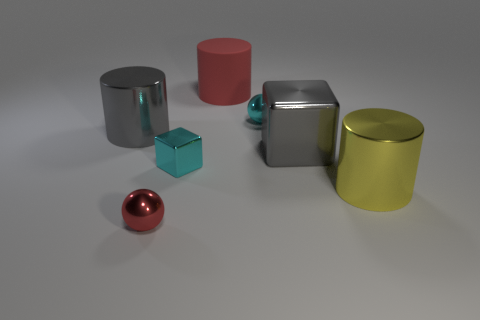What number of things are the same color as the tiny cube?
Offer a very short reply. 1. What material is the big red thing?
Provide a short and direct response. Rubber. Are there any small cyan blocks behind the large yellow object?
Your response must be concise. Yes. Is the big yellow metal object the same shape as the tiny red shiny object?
Your answer should be very brief. No. How many other things are there of the same size as the gray cube?
Your response must be concise. 3. What number of things are either tiny balls to the right of the red shiny object or cyan blocks?
Give a very brief answer. 2. What color is the big rubber thing?
Make the answer very short. Red. There is a cylinder to the right of the cyan metal sphere; what material is it?
Offer a very short reply. Metal. Does the big yellow object have the same shape as the cyan thing in front of the gray shiny block?
Offer a terse response. No. Is the number of big red cylinders greater than the number of blue shiny spheres?
Provide a succinct answer. Yes. 